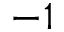<formula> <loc_0><loc_0><loc_500><loc_500>- 1</formula> 